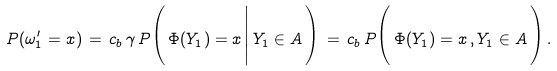Convert formula to latex. <formula><loc_0><loc_0><loc_500><loc_500>P ( \omega ^ { \prime } _ { 1 } = x ) \, = \, c _ { b } \, \gamma \, P \Big ( \, \Phi ( Y _ { 1 } ) = x \, \Big | \, Y _ { 1 } \in A \, \Big ) \, = \, c _ { b } \, P \Big ( \, \Phi ( Y _ { 1 } ) = x \, , Y _ { 1 } \in A \, \Big ) \, .</formula> 